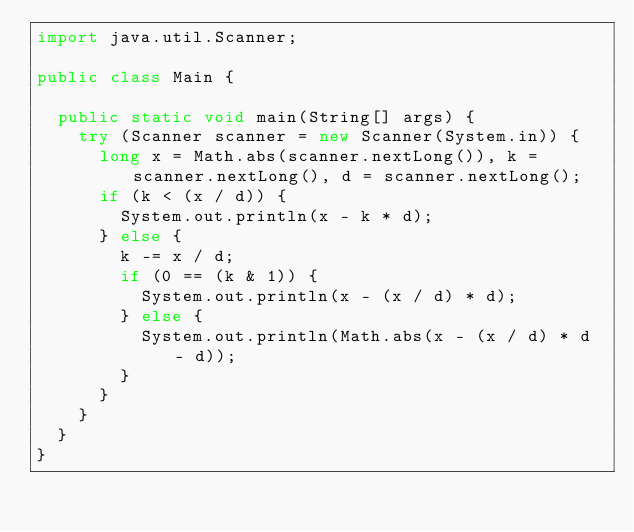<code> <loc_0><loc_0><loc_500><loc_500><_Java_>import java.util.Scanner;

public class Main {

	public static void main(String[] args) {
		try (Scanner scanner = new Scanner(System.in)) {
			long x = Math.abs(scanner.nextLong()), k = scanner.nextLong(), d = scanner.nextLong();
			if (k < (x / d)) {
				System.out.println(x - k * d);
			} else {
				k -= x / d;
				if (0 == (k & 1)) {
					System.out.println(x - (x / d) * d);
				} else {
					System.out.println(Math.abs(x - (x / d) * d - d));
				}
			}
		}
	}
}
</code> 